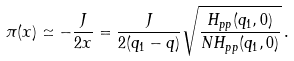<formula> <loc_0><loc_0><loc_500><loc_500>\pi ( x ) \simeq - \frac { J } { 2 x } = \frac { J } { 2 ( q _ { 1 } - q ) } \sqrt { \frac { H _ { p p } ( q _ { 1 } , 0 ) } { N H _ { p p } ( q _ { 1 } , 0 ) } } \, .</formula> 